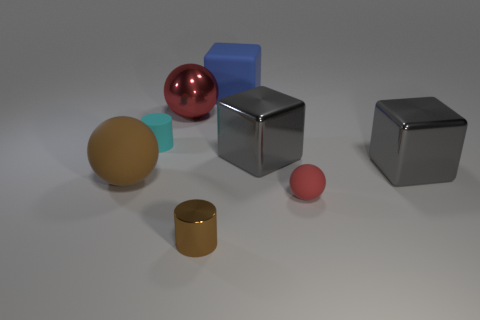Add 1 large gray objects. How many objects exist? 9 Subtract all cubes. How many objects are left? 5 Subtract all tiny purple blocks. Subtract all red metallic balls. How many objects are left? 7 Add 8 gray metal objects. How many gray metal objects are left? 10 Add 7 blue rubber objects. How many blue rubber objects exist? 8 Subtract 0 gray cylinders. How many objects are left? 8 